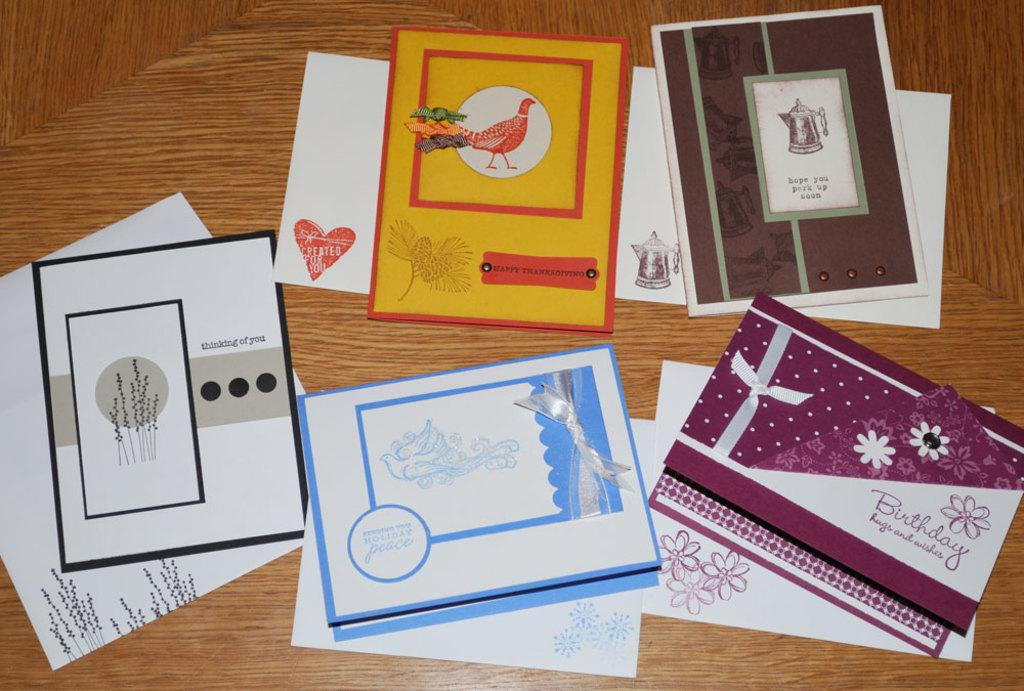<image>
Create a compact narrative representing the image presented. a card saying happy thanksgiving is mixed in with other cards 